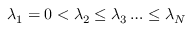Convert formula to latex. <formula><loc_0><loc_0><loc_500><loc_500>\lambda _ { 1 } = 0 < \lambda _ { 2 } \leq \lambda _ { 3 } \dots \leq \lambda _ { N }</formula> 